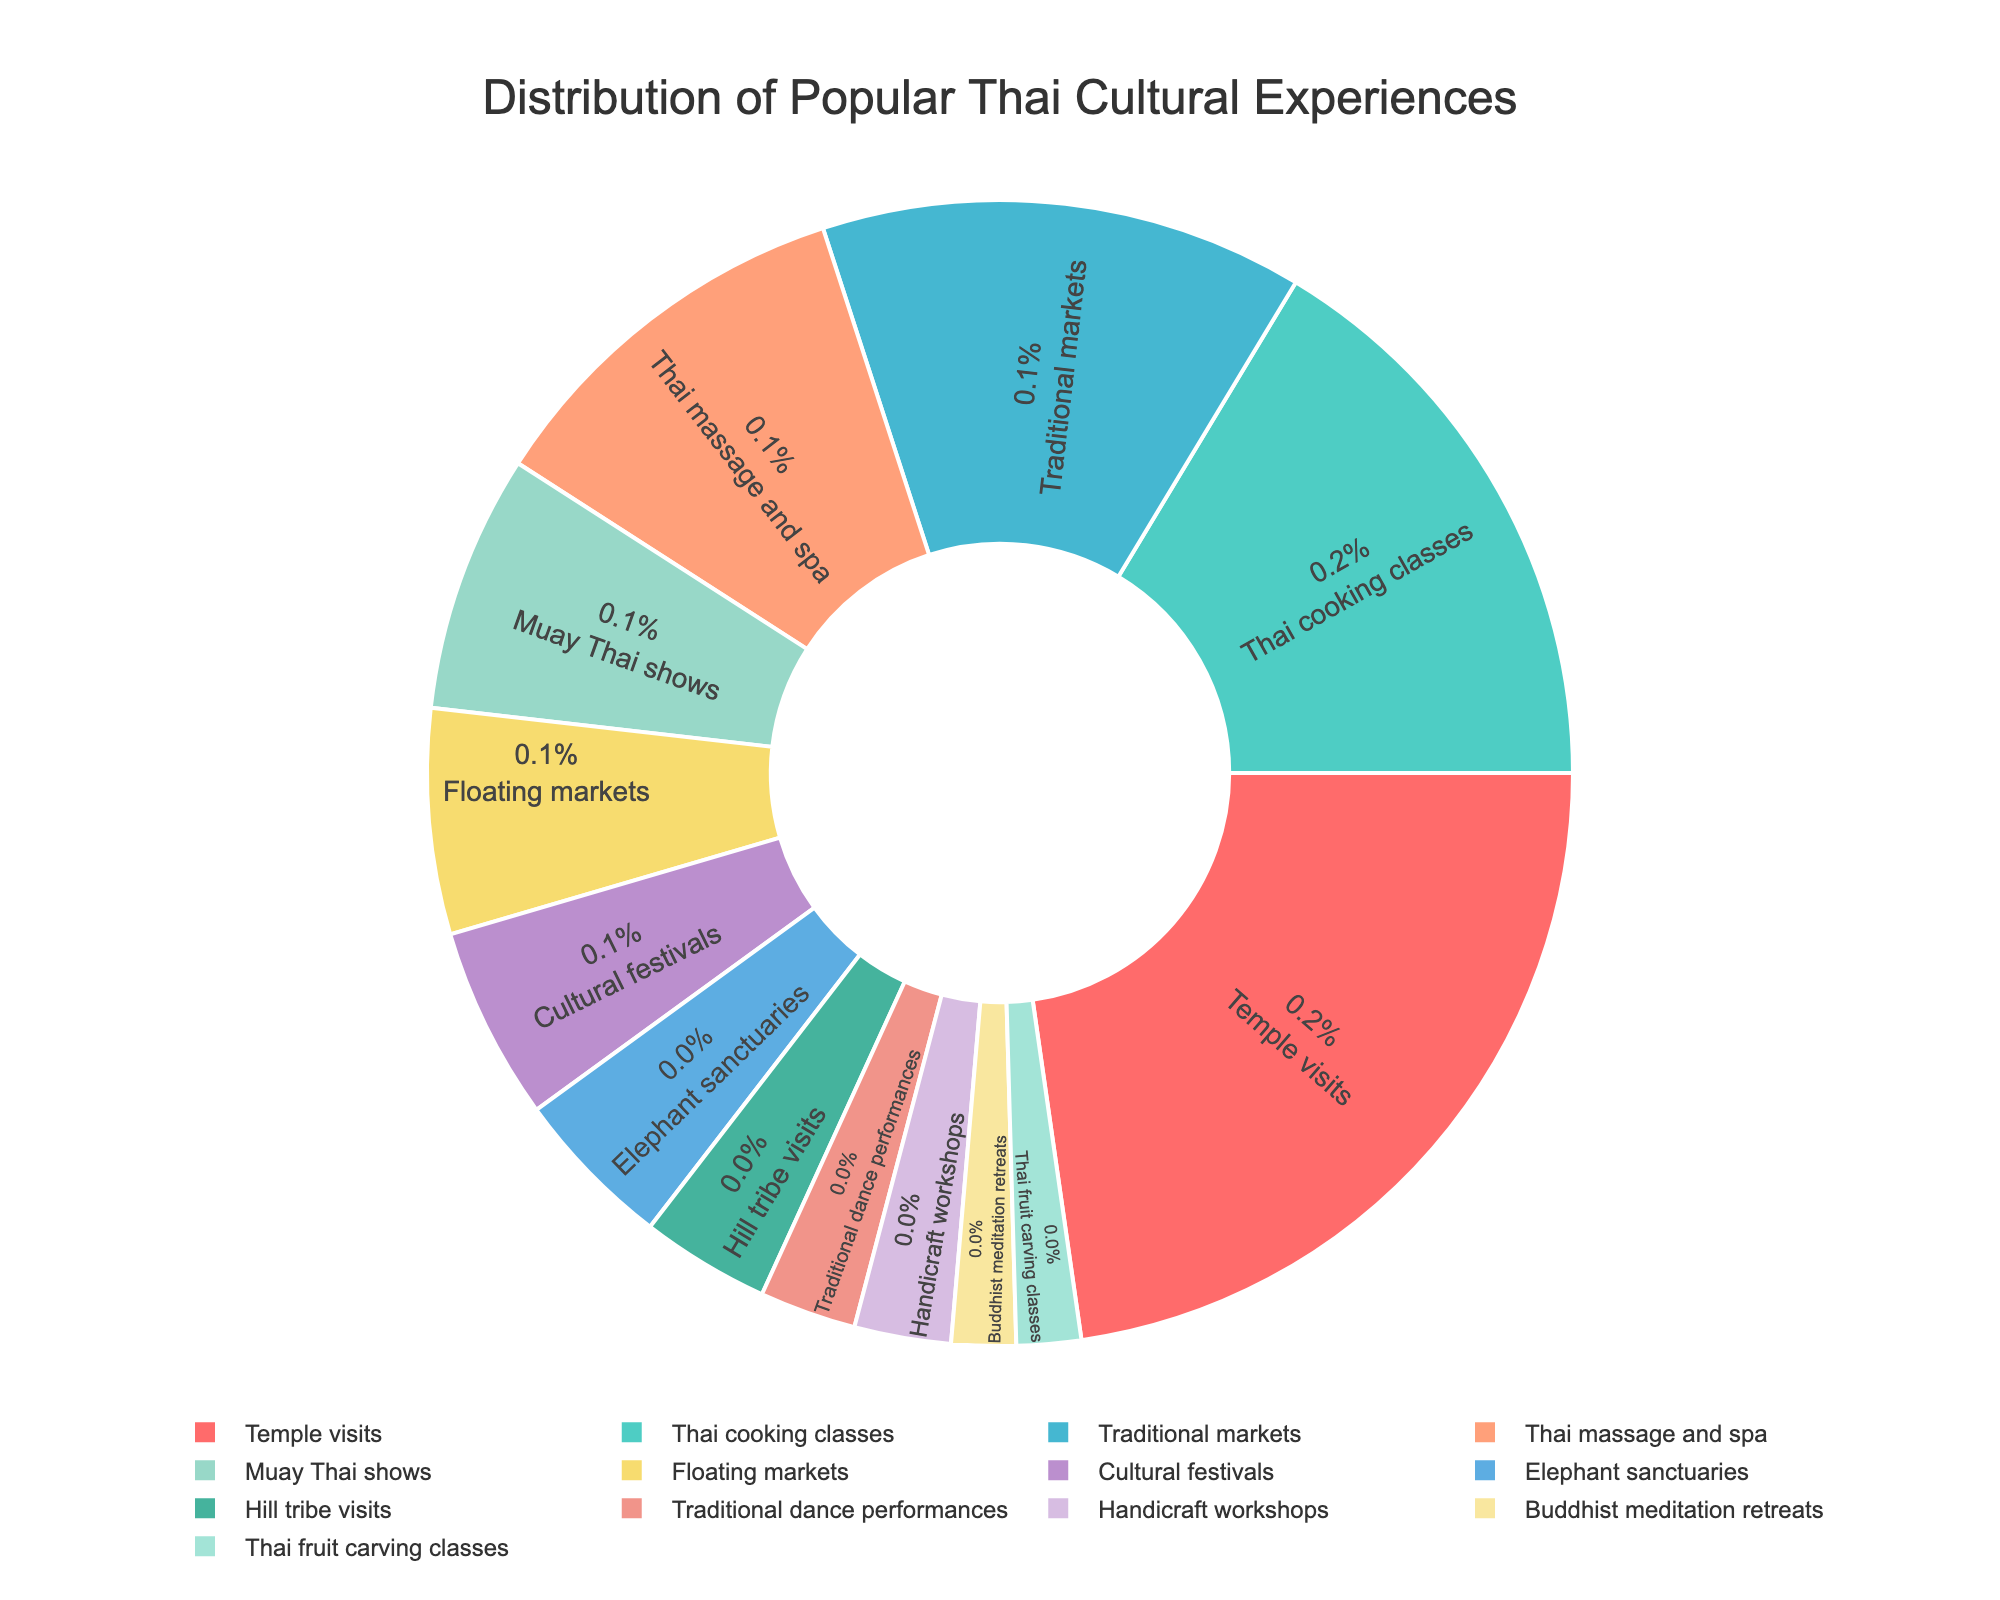What percentage of tourists participate in Thai cooking classes? Refer to the pie chart, and find the segment labeled "Thai cooking classes." The percentage is textually displayed within the segment.
Answer: 18% Which cultural experience has the lowest percentage among tourists? Locate the segment with the smallest area and the lowest numerical value. The label inside it will be the cultural experience with the lowest percentage.
Answer: Thai fruit carving classes What is the combined percentage of tourists who visit temple visits, traditional markets, and Thai massage and spa? Sum the percentages of these three experiences: Temple visits (25%) + Traditional markets (15%) + Thai massage and spa (12%).
Answer: 52% Which cultural experience attracts more tourists: Elephant sanctuaries or Cultural festivals? Compare the percentages within the segments labeled "Elephant sanctuaries" and "Cultural festivals." The larger percentage will indicate the more popular experience.
Answer: Cultural festivals How many cultural experiences individually attract more than 10% of tourists? Count the segments whose internal percentage values exceed 10%.
Answer: 3 What is the difference in percentage between the most popular and least popular cultural experiences? Subtract the percentage of the least popular experience (2% for Thai fruit carving classes) from the percentage of the most popular experience (25% for Temple visits).
Answer: 23% Which segment is represented by the color green? Identify segments associated with each color. The green segmnet is "Traditional markets."
Answer: Traditional markets What is the total percentage of tourists involved in experiences that fall below 5% individually? Sum the percentages of Hill tribe visits (4%), Traditional dance performances (3%), Handicraft workshops (3%), Buddhist meditation retreats (2%), and Thai fruit carving classes (2%). 4% + 3% + 3% + 2% + 2%
Answer: 14% Which experience has more tourist participation: Floating markets or Muay Thai shows? Compare the percentages of floating markets and Muay Thai shows. The one with the larger percentage attracts more tourists.
Answer: Muay Thai shows 